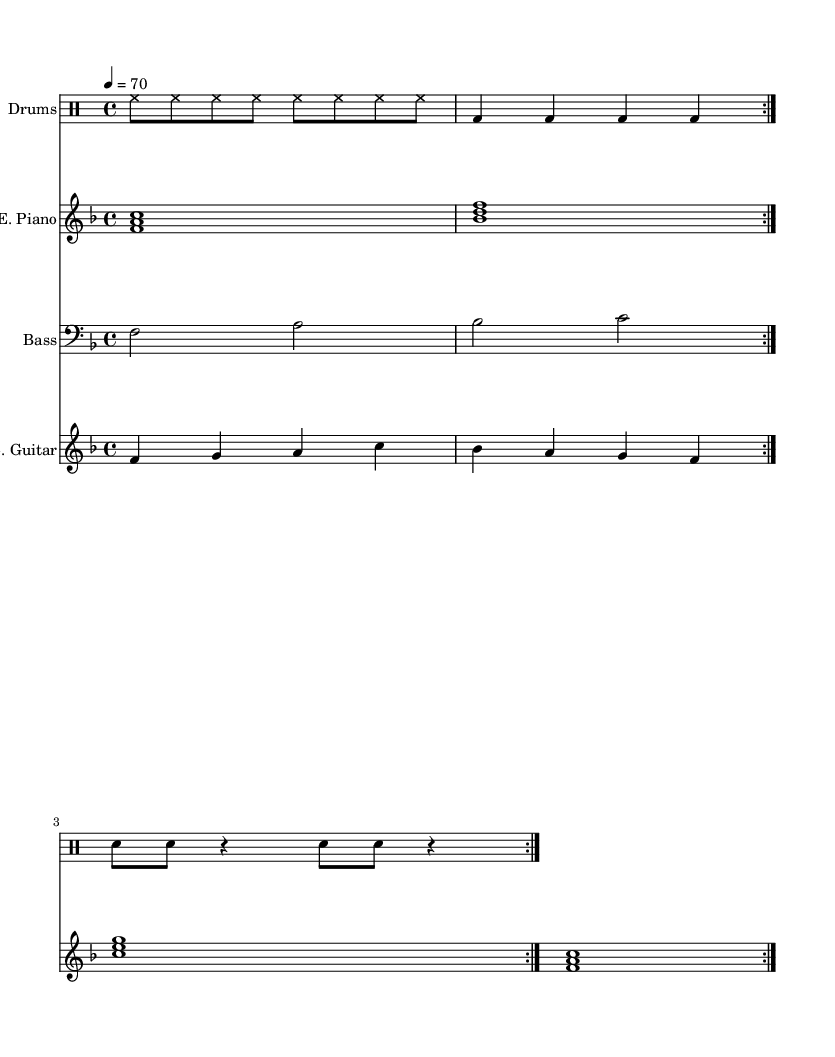What is the key signature of this music? The key signature is F major, which is indicated by one flat (B flat) in the key signature shown on the staff.
Answer: F major What is the time signature of this music? The time signature is indicated at the beginning of the score, where a four above a four signifies a 4/4 time signature.
Answer: 4/4 What is the tempo marking of this piece? The tempo marking is indicated above the staff and shows a quarter note equals 70, which signifies the speed of the piece.
Answer: 70 How many times is the drum pattern repeated? Looking at the drummode section, the notation indicates a repeat sign with "volta 2," which means the pattern is played twice.
Answer: 2 What instruments are present in this score? The score includes a Drum Staff, a Piano Staff, a Bass Staff, and a Guitar Staff, clearly labeled at the beginning of each section.
Answer: Drums, E. Piano, Bass, E. Guitar How many voices does the piano part have? The piano part is written as a single voice but includes chords; the notes are stacked vertically, indicating multiple notes played simultaneously, thus representing one voice of harmony played by the piano.
Answer: 1 